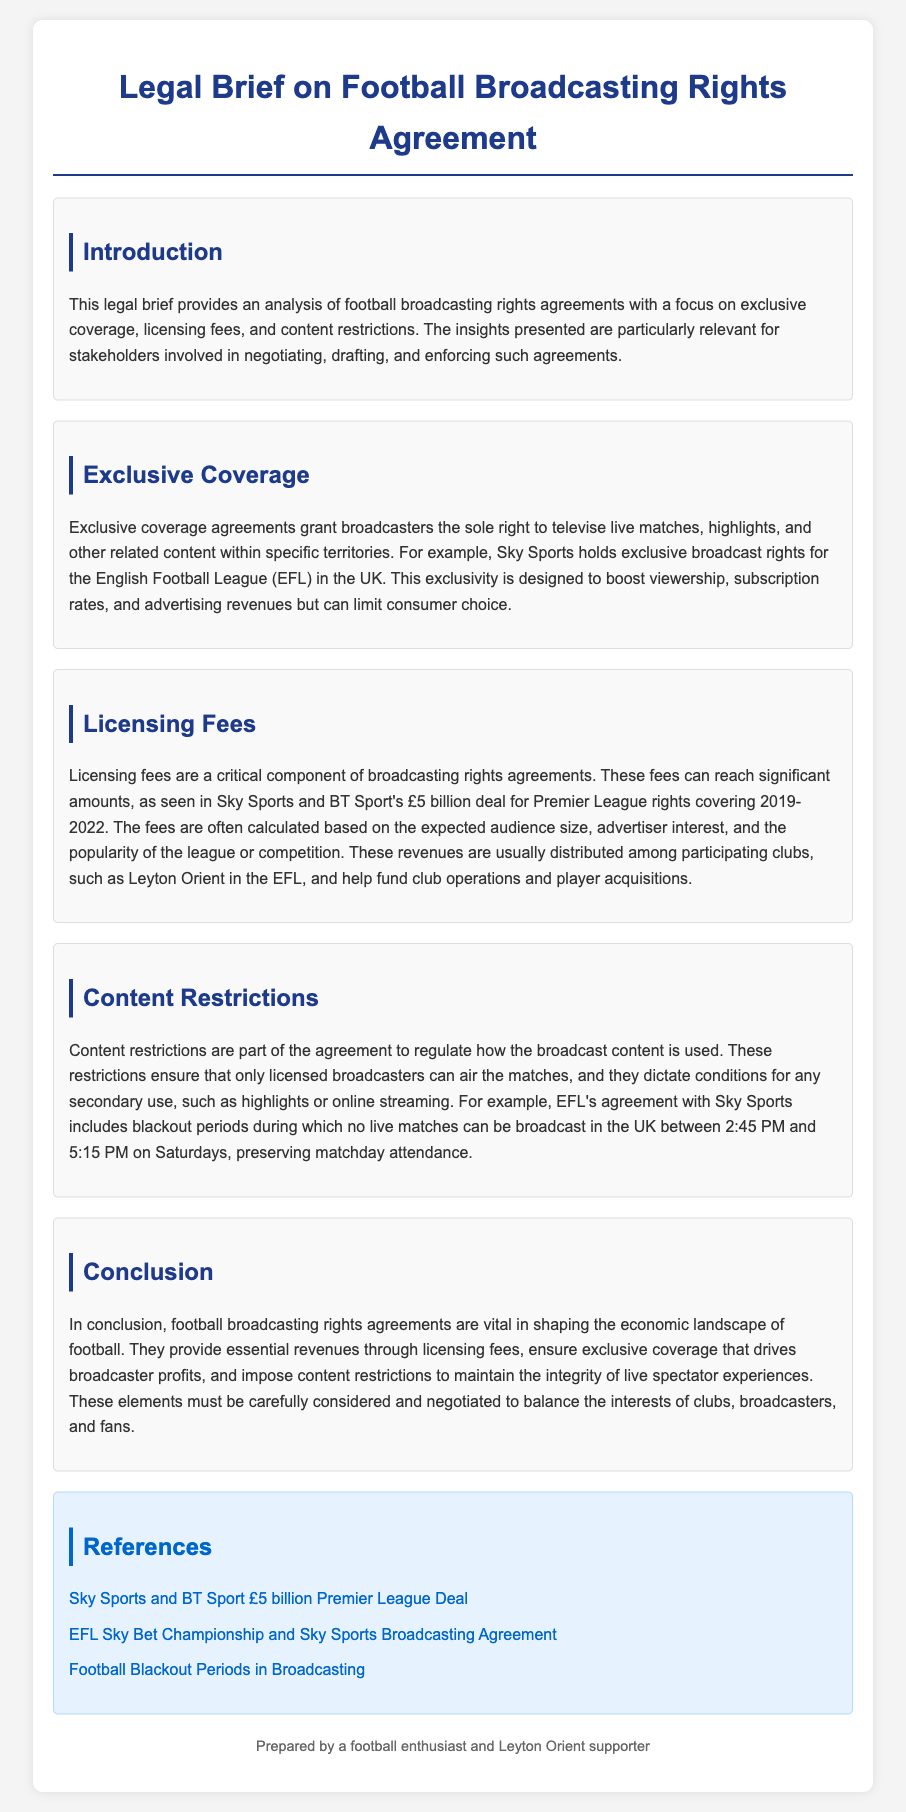what is the title of the document? The title is mentioned at the top of the document and is "Legal Brief on Football Broadcasting Rights Agreement".
Answer: Legal Brief on Football Broadcasting Rights Agreement who holds exclusive broadcast rights for the EFL in the UK? The document states that Sky Sports holds exclusive broadcast rights for the English Football League (EFL) in the UK.
Answer: Sky Sports what was the deal amount for Premier League rights covering 2019-2022? The deal amount mentioned for Premier League rights is £5 billion.
Answer: £5 billion what time frame is included in the blackout period for live matches in the UK? The blackout period stated in the document is between 2:45 PM and 5:15 PM on Saturdays.
Answer: 2:45 PM and 5:15 PM why are licensing fees significant for clubs like Leyton Orient? Licensing fees are significant because they help fund club operations and player acquisitions.
Answer: Fund club operations and player acquisitions what is a purpose of exclusive coverage agreements? The purpose is to boost viewership, subscription rates, and advertising revenues.
Answer: Boost viewership, subscription rates, and advertising revenues what kind of document is this? The document provides legal analysis and insights for stakeholders in broadcasting rights agreements.
Answer: Legal brief how do content restrictions impact broadcasting? Content restrictions impact broadcasting by regulating how the broadcast content is used and licensed.
Answer: Regulating how the broadcast content is used and licensed what is the purpose of this legal brief? The purpose is to analyze football broadcasting rights agreements focusing on specific key areas.
Answer: Analyze football broadcasting rights agreements 